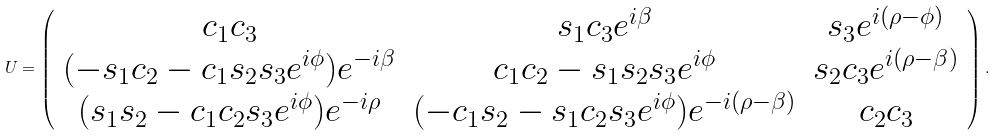Convert formula to latex. <formula><loc_0><loc_0><loc_500><loc_500>U = \left ( \begin{array} { c c c } c _ { 1 } c _ { 3 } & s _ { 1 } c _ { 3 } e ^ { i \beta } & s _ { 3 } e ^ { i ( \rho - \phi ) } \\ ( - s _ { 1 } c _ { 2 } - c _ { 1 } s _ { 2 } s _ { 3 } e ^ { i \phi } ) e ^ { - i \beta } & c _ { 1 } c _ { 2 } - s _ { 1 } s _ { 2 } s _ { 3 } e ^ { i \phi } & s _ { 2 } c _ { 3 } e ^ { i ( \rho - \beta ) } \\ ( s _ { 1 } s _ { 2 } - c _ { 1 } c _ { 2 } s _ { 3 } e ^ { i \phi } ) e ^ { - i \rho } & ( - c _ { 1 } s _ { 2 } - s _ { 1 } c _ { 2 } s _ { 3 } e ^ { i \phi } ) e ^ { - i ( \rho - \beta ) } & c _ { 2 } c _ { 3 } \\ \end{array} \right ) .</formula> 